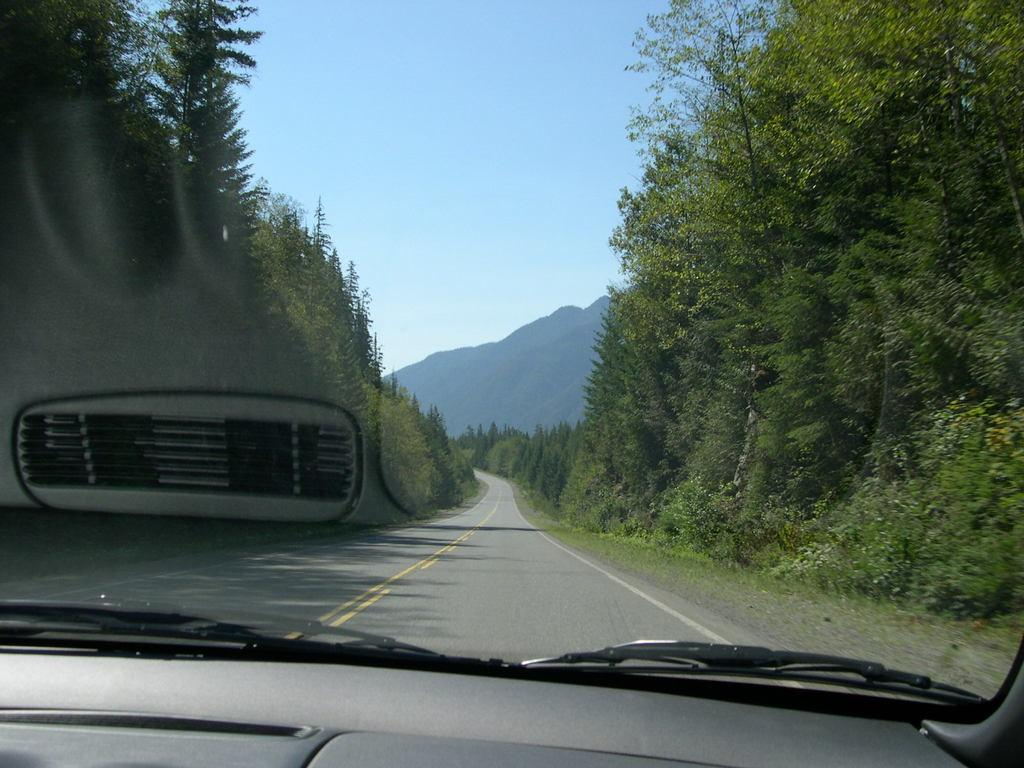What is the main subject in the foreground of the image? There is a vehicle in the foreground of the image. What can be seen through the window in the image? Trees, mountains, and a walkway are visible through the window. What is visible at the top of the image? The sky is visible at the top of the image. What type of teaching is taking place in the image? There is no teaching activity present in the image. Can you see any corn growing in the image? There is no corn visible in the image. 